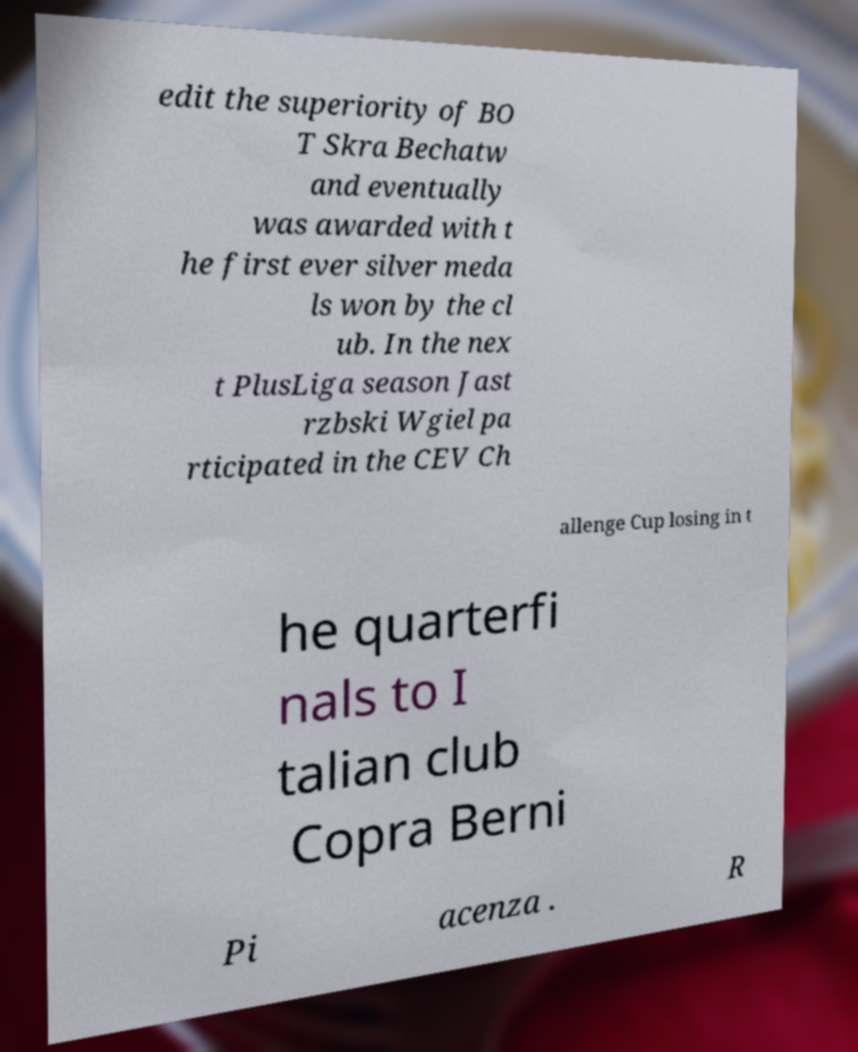I need the written content from this picture converted into text. Can you do that? edit the superiority of BO T Skra Bechatw and eventually was awarded with t he first ever silver meda ls won by the cl ub. In the nex t PlusLiga season Jast rzbski Wgiel pa rticipated in the CEV Ch allenge Cup losing in t he quarterfi nals to I talian club Copra Berni Pi acenza . R 